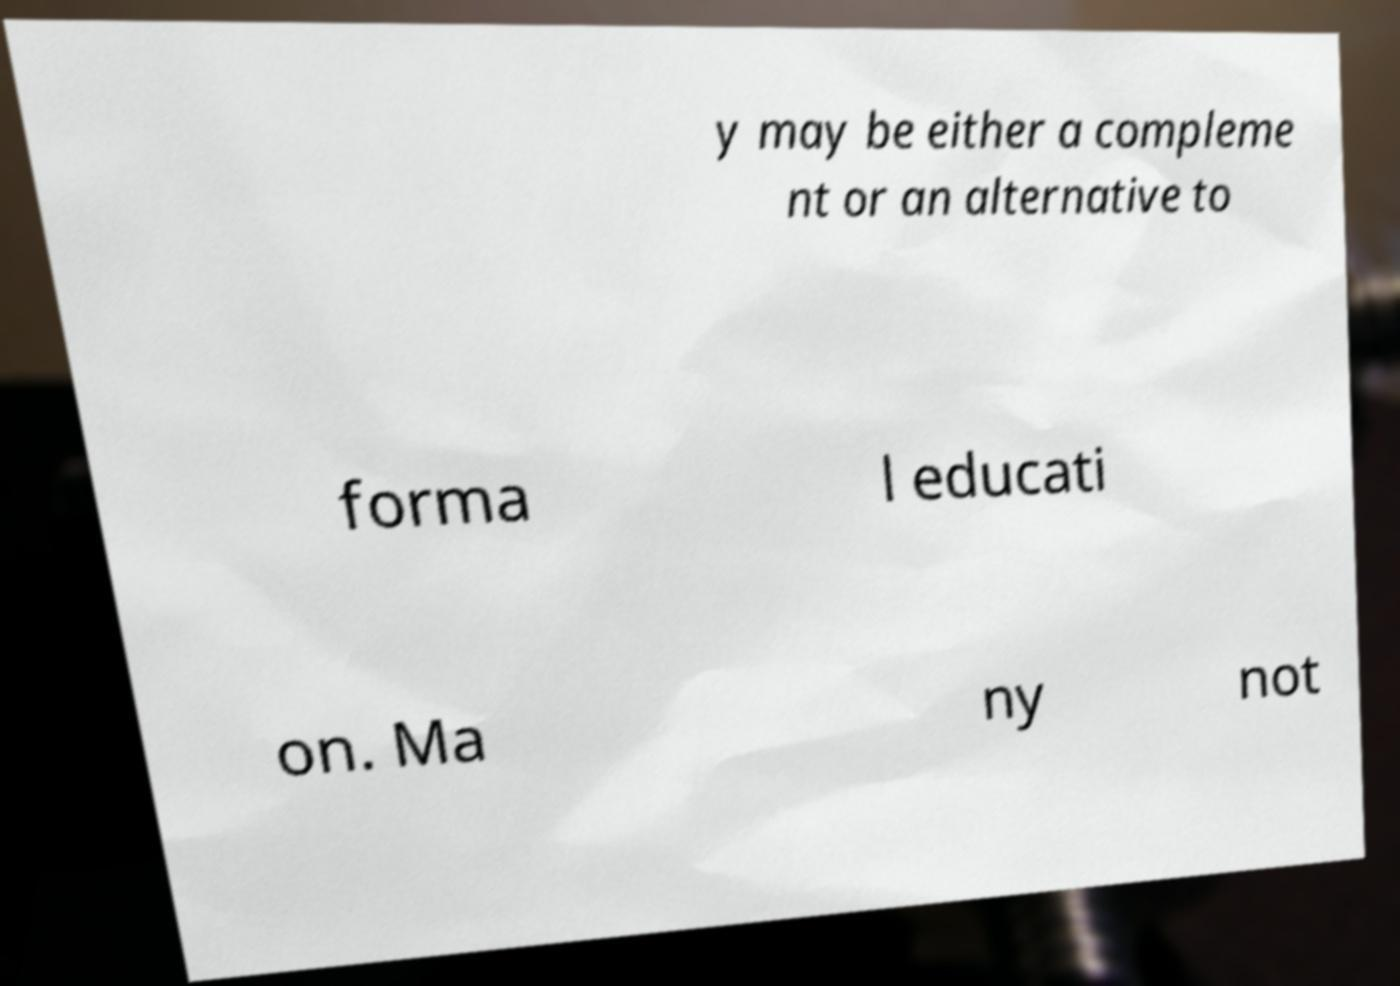Please identify and transcribe the text found in this image. y may be either a compleme nt or an alternative to forma l educati on. Ma ny not 